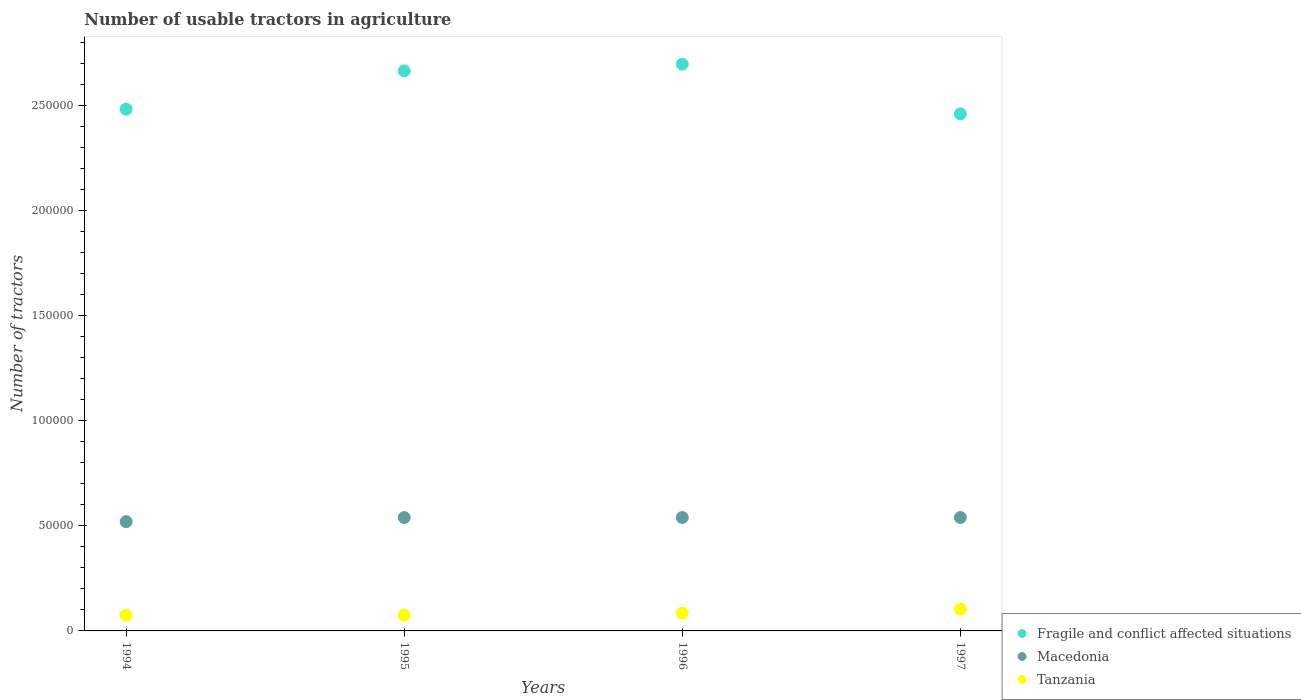What is the number of usable tractors in agriculture in Fragile and conflict affected situations in 1994?
Ensure brevity in your answer.  2.48e+05. Across all years, what is the maximum number of usable tractors in agriculture in Fragile and conflict affected situations?
Provide a short and direct response. 2.70e+05. Across all years, what is the minimum number of usable tractors in agriculture in Fragile and conflict affected situations?
Give a very brief answer. 2.46e+05. In which year was the number of usable tractors in agriculture in Tanzania maximum?
Your response must be concise. 1997. What is the total number of usable tractors in agriculture in Tanzania in the graph?
Provide a short and direct response. 3.39e+04. What is the difference between the number of usable tractors in agriculture in Macedonia in 1994 and that in 1995?
Make the answer very short. -1941. What is the difference between the number of usable tractors in agriculture in Tanzania in 1994 and the number of usable tractors in agriculture in Fragile and conflict affected situations in 1997?
Keep it short and to the point. -2.39e+05. What is the average number of usable tractors in agriculture in Macedonia per year?
Your response must be concise. 5.35e+04. In the year 1997, what is the difference between the number of usable tractors in agriculture in Macedonia and number of usable tractors in agriculture in Fragile and conflict affected situations?
Ensure brevity in your answer.  -1.92e+05. What is the ratio of the number of usable tractors in agriculture in Fragile and conflict affected situations in 1994 to that in 1997?
Keep it short and to the point. 1.01. What is the difference between the highest and the second highest number of usable tractors in agriculture in Tanzania?
Your response must be concise. 1955. What is the difference between the highest and the lowest number of usable tractors in agriculture in Fragile and conflict affected situations?
Make the answer very short. 2.37e+04. Is it the case that in every year, the sum of the number of usable tractors in agriculture in Macedonia and number of usable tractors in agriculture in Tanzania  is greater than the number of usable tractors in agriculture in Fragile and conflict affected situations?
Your response must be concise. No. Is the number of usable tractors in agriculture in Macedonia strictly less than the number of usable tractors in agriculture in Fragile and conflict affected situations over the years?
Give a very brief answer. Yes. What is the difference between two consecutive major ticks on the Y-axis?
Offer a very short reply. 5.00e+04. Are the values on the major ticks of Y-axis written in scientific E-notation?
Make the answer very short. No. Does the graph contain any zero values?
Make the answer very short. No. Where does the legend appear in the graph?
Keep it short and to the point. Bottom right. How many legend labels are there?
Offer a very short reply. 3. What is the title of the graph?
Your response must be concise. Number of usable tractors in agriculture. What is the label or title of the Y-axis?
Provide a succinct answer. Number of tractors. What is the Number of tractors in Fragile and conflict affected situations in 1994?
Provide a short and direct response. 2.48e+05. What is the Number of tractors of Macedonia in 1994?
Provide a succinct answer. 5.20e+04. What is the Number of tractors of Tanzania in 1994?
Keep it short and to the point. 7500. What is the Number of tractors of Fragile and conflict affected situations in 1995?
Your answer should be compact. 2.67e+05. What is the Number of tractors of Macedonia in 1995?
Make the answer very short. 5.40e+04. What is the Number of tractors of Tanzania in 1995?
Your response must be concise. 7525. What is the Number of tractors in Fragile and conflict affected situations in 1996?
Your answer should be compact. 2.70e+05. What is the Number of tractors in Macedonia in 1996?
Your answer should be compact. 5.40e+04. What is the Number of tractors in Tanzania in 1996?
Provide a succinct answer. 8480. What is the Number of tractors of Fragile and conflict affected situations in 1997?
Keep it short and to the point. 2.46e+05. What is the Number of tractors in Macedonia in 1997?
Your answer should be compact. 5.40e+04. What is the Number of tractors of Tanzania in 1997?
Offer a terse response. 1.04e+04. Across all years, what is the maximum Number of tractors of Fragile and conflict affected situations?
Make the answer very short. 2.70e+05. Across all years, what is the maximum Number of tractors of Macedonia?
Ensure brevity in your answer.  5.40e+04. Across all years, what is the maximum Number of tractors in Tanzania?
Your response must be concise. 1.04e+04. Across all years, what is the minimum Number of tractors of Fragile and conflict affected situations?
Your answer should be compact. 2.46e+05. Across all years, what is the minimum Number of tractors in Macedonia?
Provide a succinct answer. 5.20e+04. Across all years, what is the minimum Number of tractors of Tanzania?
Offer a very short reply. 7500. What is the total Number of tractors of Fragile and conflict affected situations in the graph?
Keep it short and to the point. 1.03e+06. What is the total Number of tractors of Macedonia in the graph?
Your answer should be very brief. 2.14e+05. What is the total Number of tractors in Tanzania in the graph?
Offer a terse response. 3.39e+04. What is the difference between the Number of tractors of Fragile and conflict affected situations in 1994 and that in 1995?
Provide a succinct answer. -1.82e+04. What is the difference between the Number of tractors of Macedonia in 1994 and that in 1995?
Your answer should be compact. -1941. What is the difference between the Number of tractors of Tanzania in 1994 and that in 1995?
Your response must be concise. -25. What is the difference between the Number of tractors in Fragile and conflict affected situations in 1994 and that in 1996?
Keep it short and to the point. -2.14e+04. What is the difference between the Number of tractors of Macedonia in 1994 and that in 1996?
Offer a very short reply. -1964. What is the difference between the Number of tractors in Tanzania in 1994 and that in 1996?
Give a very brief answer. -980. What is the difference between the Number of tractors in Fragile and conflict affected situations in 1994 and that in 1997?
Your answer should be very brief. 2224. What is the difference between the Number of tractors of Macedonia in 1994 and that in 1997?
Give a very brief answer. -1964. What is the difference between the Number of tractors of Tanzania in 1994 and that in 1997?
Provide a succinct answer. -2935. What is the difference between the Number of tractors in Fragile and conflict affected situations in 1995 and that in 1996?
Provide a succinct answer. -3232. What is the difference between the Number of tractors of Tanzania in 1995 and that in 1996?
Provide a succinct answer. -955. What is the difference between the Number of tractors in Fragile and conflict affected situations in 1995 and that in 1997?
Your answer should be very brief. 2.04e+04. What is the difference between the Number of tractors of Tanzania in 1995 and that in 1997?
Ensure brevity in your answer.  -2910. What is the difference between the Number of tractors of Fragile and conflict affected situations in 1996 and that in 1997?
Offer a very short reply. 2.37e+04. What is the difference between the Number of tractors of Macedonia in 1996 and that in 1997?
Your response must be concise. 0. What is the difference between the Number of tractors of Tanzania in 1996 and that in 1997?
Offer a terse response. -1955. What is the difference between the Number of tractors in Fragile and conflict affected situations in 1994 and the Number of tractors in Macedonia in 1995?
Your answer should be compact. 1.94e+05. What is the difference between the Number of tractors of Fragile and conflict affected situations in 1994 and the Number of tractors of Tanzania in 1995?
Make the answer very short. 2.41e+05. What is the difference between the Number of tractors of Macedonia in 1994 and the Number of tractors of Tanzania in 1995?
Provide a short and direct response. 4.45e+04. What is the difference between the Number of tractors in Fragile and conflict affected situations in 1994 and the Number of tractors in Macedonia in 1996?
Make the answer very short. 1.94e+05. What is the difference between the Number of tractors of Fragile and conflict affected situations in 1994 and the Number of tractors of Tanzania in 1996?
Keep it short and to the point. 2.40e+05. What is the difference between the Number of tractors of Macedonia in 1994 and the Number of tractors of Tanzania in 1996?
Provide a short and direct response. 4.36e+04. What is the difference between the Number of tractors in Fragile and conflict affected situations in 1994 and the Number of tractors in Macedonia in 1997?
Your answer should be compact. 1.94e+05. What is the difference between the Number of tractors in Fragile and conflict affected situations in 1994 and the Number of tractors in Tanzania in 1997?
Offer a very short reply. 2.38e+05. What is the difference between the Number of tractors of Macedonia in 1994 and the Number of tractors of Tanzania in 1997?
Make the answer very short. 4.16e+04. What is the difference between the Number of tractors of Fragile and conflict affected situations in 1995 and the Number of tractors of Macedonia in 1996?
Ensure brevity in your answer.  2.13e+05. What is the difference between the Number of tractors in Fragile and conflict affected situations in 1995 and the Number of tractors in Tanzania in 1996?
Your response must be concise. 2.58e+05. What is the difference between the Number of tractors of Macedonia in 1995 and the Number of tractors of Tanzania in 1996?
Make the answer very short. 4.55e+04. What is the difference between the Number of tractors of Fragile and conflict affected situations in 1995 and the Number of tractors of Macedonia in 1997?
Your answer should be compact. 2.13e+05. What is the difference between the Number of tractors in Fragile and conflict affected situations in 1995 and the Number of tractors in Tanzania in 1997?
Keep it short and to the point. 2.56e+05. What is the difference between the Number of tractors of Macedonia in 1995 and the Number of tractors of Tanzania in 1997?
Offer a terse response. 4.35e+04. What is the difference between the Number of tractors of Fragile and conflict affected situations in 1996 and the Number of tractors of Macedonia in 1997?
Your answer should be very brief. 2.16e+05. What is the difference between the Number of tractors in Fragile and conflict affected situations in 1996 and the Number of tractors in Tanzania in 1997?
Give a very brief answer. 2.59e+05. What is the difference between the Number of tractors of Macedonia in 1996 and the Number of tractors of Tanzania in 1997?
Make the answer very short. 4.36e+04. What is the average Number of tractors of Fragile and conflict affected situations per year?
Give a very brief answer. 2.58e+05. What is the average Number of tractors in Macedonia per year?
Give a very brief answer. 5.35e+04. What is the average Number of tractors in Tanzania per year?
Offer a terse response. 8485. In the year 1994, what is the difference between the Number of tractors in Fragile and conflict affected situations and Number of tractors in Macedonia?
Provide a short and direct response. 1.96e+05. In the year 1994, what is the difference between the Number of tractors of Fragile and conflict affected situations and Number of tractors of Tanzania?
Make the answer very short. 2.41e+05. In the year 1994, what is the difference between the Number of tractors in Macedonia and Number of tractors in Tanzania?
Your response must be concise. 4.45e+04. In the year 1995, what is the difference between the Number of tractors of Fragile and conflict affected situations and Number of tractors of Macedonia?
Give a very brief answer. 2.13e+05. In the year 1995, what is the difference between the Number of tractors of Fragile and conflict affected situations and Number of tractors of Tanzania?
Offer a very short reply. 2.59e+05. In the year 1995, what is the difference between the Number of tractors in Macedonia and Number of tractors in Tanzania?
Provide a succinct answer. 4.65e+04. In the year 1996, what is the difference between the Number of tractors of Fragile and conflict affected situations and Number of tractors of Macedonia?
Your answer should be compact. 2.16e+05. In the year 1996, what is the difference between the Number of tractors of Fragile and conflict affected situations and Number of tractors of Tanzania?
Provide a short and direct response. 2.61e+05. In the year 1996, what is the difference between the Number of tractors in Macedonia and Number of tractors in Tanzania?
Your answer should be compact. 4.55e+04. In the year 1997, what is the difference between the Number of tractors in Fragile and conflict affected situations and Number of tractors in Macedonia?
Your answer should be compact. 1.92e+05. In the year 1997, what is the difference between the Number of tractors in Fragile and conflict affected situations and Number of tractors in Tanzania?
Your answer should be compact. 2.36e+05. In the year 1997, what is the difference between the Number of tractors of Macedonia and Number of tractors of Tanzania?
Your answer should be compact. 4.36e+04. What is the ratio of the Number of tractors in Fragile and conflict affected situations in 1994 to that in 1995?
Your answer should be very brief. 0.93. What is the ratio of the Number of tractors in Macedonia in 1994 to that in 1995?
Offer a very short reply. 0.96. What is the ratio of the Number of tractors of Fragile and conflict affected situations in 1994 to that in 1996?
Give a very brief answer. 0.92. What is the ratio of the Number of tractors in Macedonia in 1994 to that in 1996?
Your response must be concise. 0.96. What is the ratio of the Number of tractors of Tanzania in 1994 to that in 1996?
Offer a very short reply. 0.88. What is the ratio of the Number of tractors of Macedonia in 1994 to that in 1997?
Provide a short and direct response. 0.96. What is the ratio of the Number of tractors of Tanzania in 1994 to that in 1997?
Your answer should be very brief. 0.72. What is the ratio of the Number of tractors in Macedonia in 1995 to that in 1996?
Your response must be concise. 1. What is the ratio of the Number of tractors of Tanzania in 1995 to that in 1996?
Offer a very short reply. 0.89. What is the ratio of the Number of tractors of Fragile and conflict affected situations in 1995 to that in 1997?
Offer a terse response. 1.08. What is the ratio of the Number of tractors in Tanzania in 1995 to that in 1997?
Give a very brief answer. 0.72. What is the ratio of the Number of tractors in Fragile and conflict affected situations in 1996 to that in 1997?
Keep it short and to the point. 1.1. What is the ratio of the Number of tractors in Macedonia in 1996 to that in 1997?
Offer a terse response. 1. What is the ratio of the Number of tractors in Tanzania in 1996 to that in 1997?
Give a very brief answer. 0.81. What is the difference between the highest and the second highest Number of tractors in Fragile and conflict affected situations?
Your answer should be compact. 3232. What is the difference between the highest and the second highest Number of tractors of Tanzania?
Provide a succinct answer. 1955. What is the difference between the highest and the lowest Number of tractors of Fragile and conflict affected situations?
Keep it short and to the point. 2.37e+04. What is the difference between the highest and the lowest Number of tractors of Macedonia?
Ensure brevity in your answer.  1964. What is the difference between the highest and the lowest Number of tractors of Tanzania?
Provide a short and direct response. 2935. 